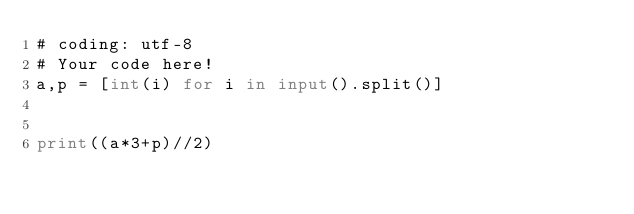Convert code to text. <code><loc_0><loc_0><loc_500><loc_500><_Python_># coding: utf-8
# Your code here!
a,p = [int(i) for i in input().split()]


print((a*3+p)//2)
</code> 